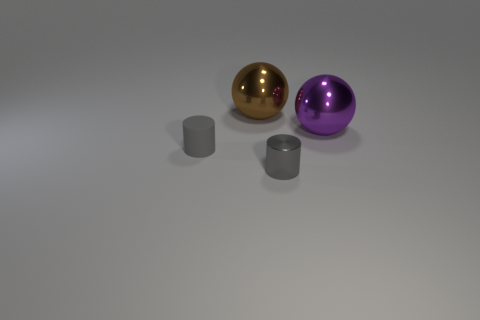Do the tiny metallic object and the small rubber object have the same color?
Give a very brief answer. Yes. Are there fewer gray matte cylinders than large shiny balls?
Your response must be concise. Yes. Is there a large thing that is to the left of the big metallic sphere behind the purple metallic sphere?
Your answer should be compact. No. There is a large thing that is made of the same material as the big purple ball; what is its shape?
Your response must be concise. Sphere. Is there anything else of the same color as the metallic cylinder?
Provide a succinct answer. Yes. There is another small gray thing that is the same shape as the gray matte thing; what is its material?
Keep it short and to the point. Metal. What number of other objects are there of the same size as the purple metallic sphere?
Make the answer very short. 1. There is a metal cylinder that is the same color as the rubber cylinder; what size is it?
Your answer should be very brief. Small. There is a gray thing on the right side of the gray rubber thing; is it the same shape as the large purple metal object?
Make the answer very short. No. There is a metal object behind the big purple shiny object; what is its shape?
Ensure brevity in your answer.  Sphere. 